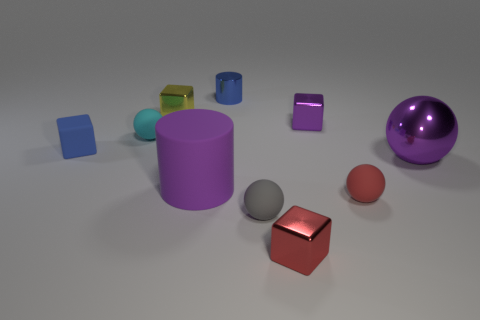Subtract 1 cubes. How many cubes are left? 3 Subtract all spheres. How many objects are left? 6 Subtract 0 brown spheres. How many objects are left? 10 Subtract all cyan cubes. Subtract all blue cylinders. How many objects are left? 9 Add 4 red balls. How many red balls are left? 5 Add 2 tiny blue matte blocks. How many tiny blue matte blocks exist? 3 